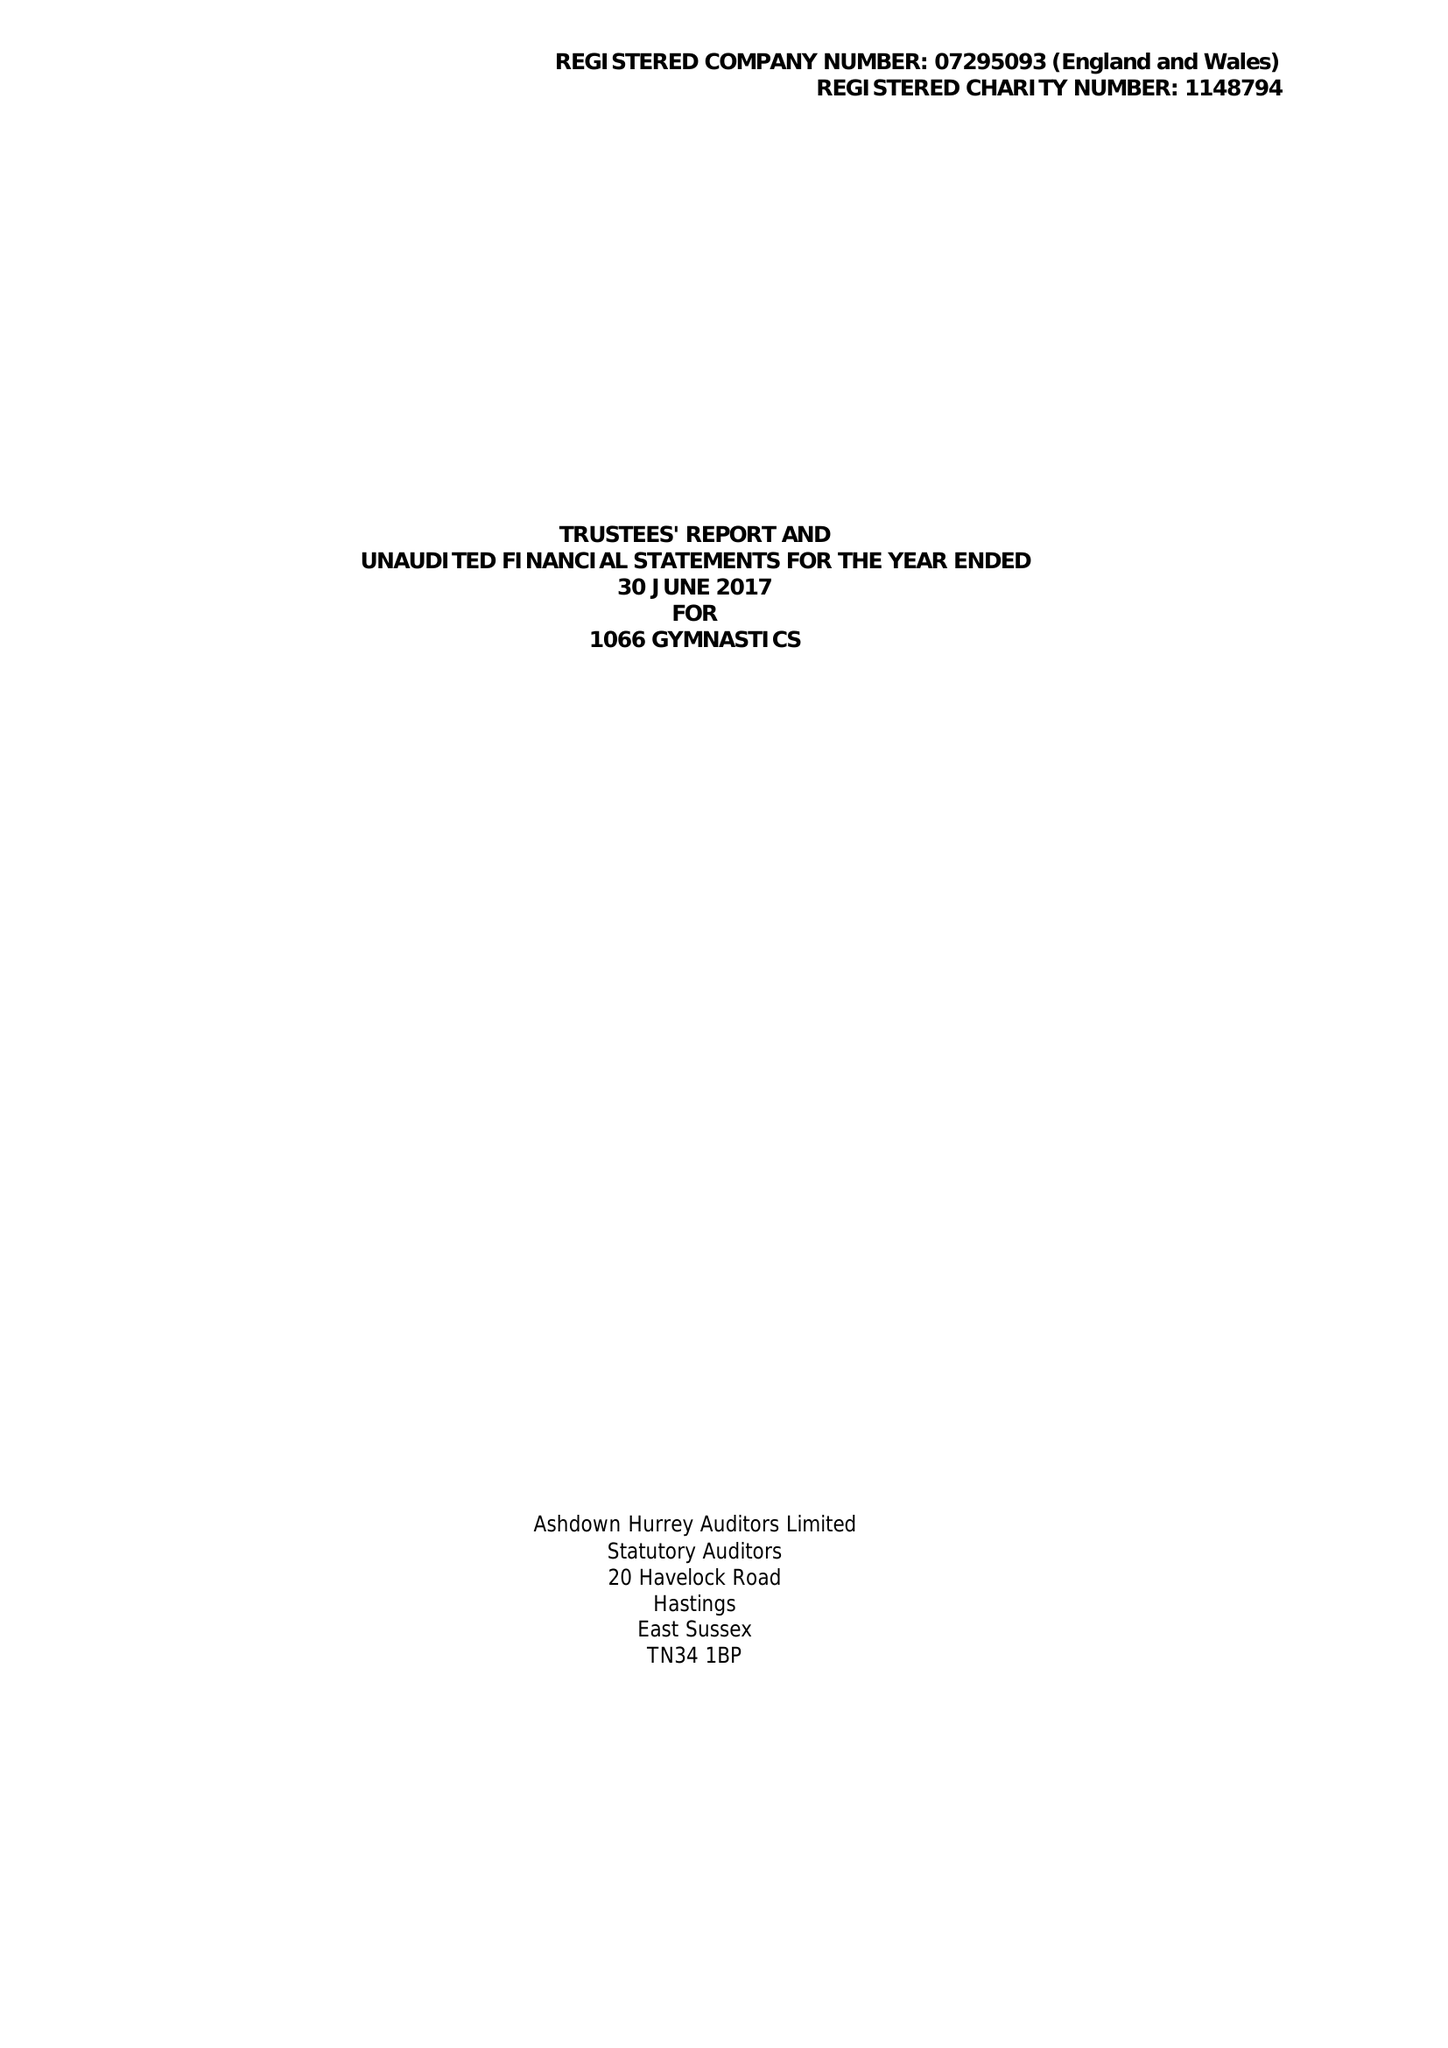What is the value for the address__post_town?
Answer the question using a single word or phrase. BEXHILL-ON-SEA 